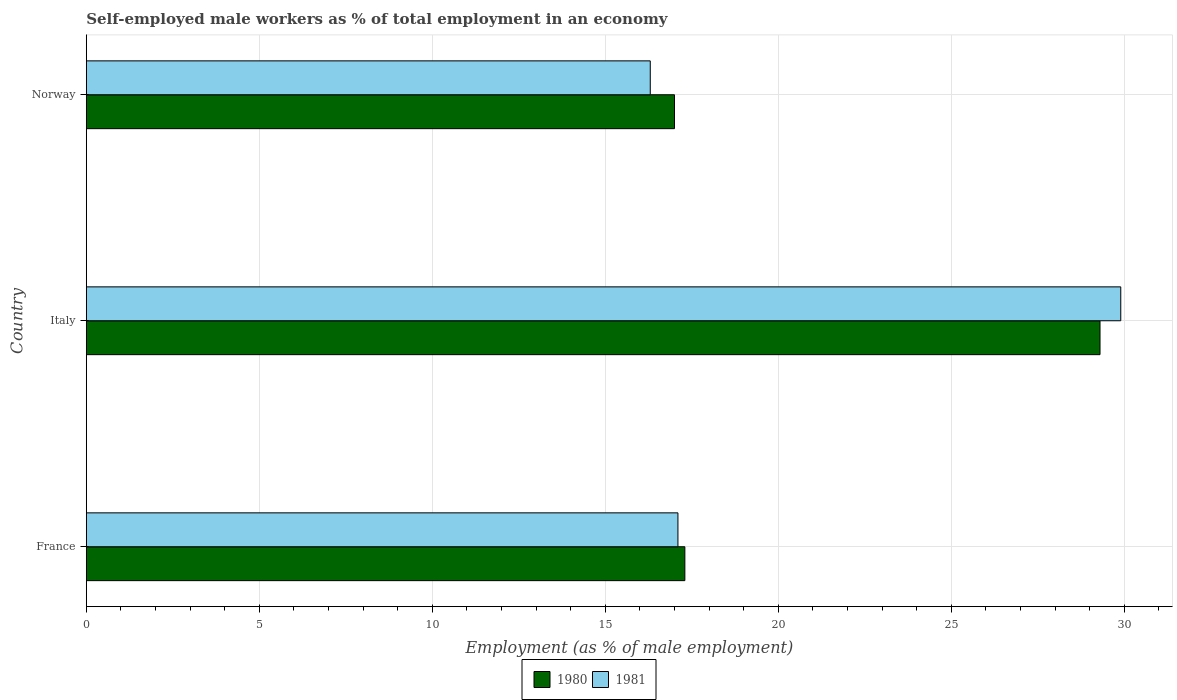How many groups of bars are there?
Keep it short and to the point. 3. Are the number of bars on each tick of the Y-axis equal?
Provide a short and direct response. Yes. How many bars are there on the 1st tick from the bottom?
Ensure brevity in your answer.  2. What is the percentage of self-employed male workers in 1981 in Italy?
Your answer should be compact. 29.9. Across all countries, what is the maximum percentage of self-employed male workers in 1981?
Provide a short and direct response. 29.9. In which country was the percentage of self-employed male workers in 1981 maximum?
Provide a succinct answer. Italy. What is the total percentage of self-employed male workers in 1981 in the graph?
Keep it short and to the point. 63.3. What is the difference between the percentage of self-employed male workers in 1980 in France and that in Italy?
Your response must be concise. -12. What is the average percentage of self-employed male workers in 1981 per country?
Your response must be concise. 21.1. What is the difference between the percentage of self-employed male workers in 1981 and percentage of self-employed male workers in 1980 in Italy?
Your answer should be compact. 0.6. What is the ratio of the percentage of self-employed male workers in 1980 in France to that in Norway?
Provide a short and direct response. 1.02. Is the percentage of self-employed male workers in 1980 in France less than that in Italy?
Provide a short and direct response. Yes. What is the difference between the highest and the second highest percentage of self-employed male workers in 1981?
Offer a very short reply. 12.8. What is the difference between the highest and the lowest percentage of self-employed male workers in 1980?
Ensure brevity in your answer.  12.3. What does the 1st bar from the top in Italy represents?
Ensure brevity in your answer.  1981. How many bars are there?
Ensure brevity in your answer.  6. Are all the bars in the graph horizontal?
Provide a short and direct response. Yes. Are the values on the major ticks of X-axis written in scientific E-notation?
Give a very brief answer. No. Does the graph contain any zero values?
Offer a terse response. No. Where does the legend appear in the graph?
Your answer should be very brief. Bottom center. How many legend labels are there?
Your answer should be very brief. 2. How are the legend labels stacked?
Offer a terse response. Horizontal. What is the title of the graph?
Offer a very short reply. Self-employed male workers as % of total employment in an economy. Does "1993" appear as one of the legend labels in the graph?
Provide a short and direct response. No. What is the label or title of the X-axis?
Keep it short and to the point. Employment (as % of male employment). What is the label or title of the Y-axis?
Offer a terse response. Country. What is the Employment (as % of male employment) of 1980 in France?
Provide a short and direct response. 17.3. What is the Employment (as % of male employment) in 1981 in France?
Your answer should be very brief. 17.1. What is the Employment (as % of male employment) in 1980 in Italy?
Keep it short and to the point. 29.3. What is the Employment (as % of male employment) in 1981 in Italy?
Your response must be concise. 29.9. What is the Employment (as % of male employment) in 1980 in Norway?
Provide a short and direct response. 17. What is the Employment (as % of male employment) of 1981 in Norway?
Your response must be concise. 16.3. Across all countries, what is the maximum Employment (as % of male employment) in 1980?
Make the answer very short. 29.3. Across all countries, what is the maximum Employment (as % of male employment) of 1981?
Your response must be concise. 29.9. Across all countries, what is the minimum Employment (as % of male employment) of 1980?
Offer a very short reply. 17. Across all countries, what is the minimum Employment (as % of male employment) in 1981?
Ensure brevity in your answer.  16.3. What is the total Employment (as % of male employment) of 1980 in the graph?
Your answer should be compact. 63.6. What is the total Employment (as % of male employment) of 1981 in the graph?
Your answer should be compact. 63.3. What is the difference between the Employment (as % of male employment) of 1981 in France and that in Norway?
Provide a short and direct response. 0.8. What is the difference between the Employment (as % of male employment) of 1981 in Italy and that in Norway?
Your answer should be compact. 13.6. What is the difference between the Employment (as % of male employment) of 1980 in France and the Employment (as % of male employment) of 1981 in Italy?
Offer a terse response. -12.6. What is the difference between the Employment (as % of male employment) of 1980 in Italy and the Employment (as % of male employment) of 1981 in Norway?
Ensure brevity in your answer.  13. What is the average Employment (as % of male employment) in 1980 per country?
Give a very brief answer. 21.2. What is the average Employment (as % of male employment) of 1981 per country?
Offer a terse response. 21.1. What is the difference between the Employment (as % of male employment) of 1980 and Employment (as % of male employment) of 1981 in France?
Your answer should be very brief. 0.2. What is the difference between the Employment (as % of male employment) of 1980 and Employment (as % of male employment) of 1981 in Norway?
Provide a short and direct response. 0.7. What is the ratio of the Employment (as % of male employment) of 1980 in France to that in Italy?
Offer a very short reply. 0.59. What is the ratio of the Employment (as % of male employment) in 1981 in France to that in Italy?
Your answer should be compact. 0.57. What is the ratio of the Employment (as % of male employment) in 1980 in France to that in Norway?
Provide a short and direct response. 1.02. What is the ratio of the Employment (as % of male employment) of 1981 in France to that in Norway?
Provide a short and direct response. 1.05. What is the ratio of the Employment (as % of male employment) in 1980 in Italy to that in Norway?
Your answer should be compact. 1.72. What is the ratio of the Employment (as % of male employment) in 1981 in Italy to that in Norway?
Your answer should be compact. 1.83. What is the difference between the highest and the lowest Employment (as % of male employment) in 1980?
Give a very brief answer. 12.3. What is the difference between the highest and the lowest Employment (as % of male employment) of 1981?
Your answer should be compact. 13.6. 